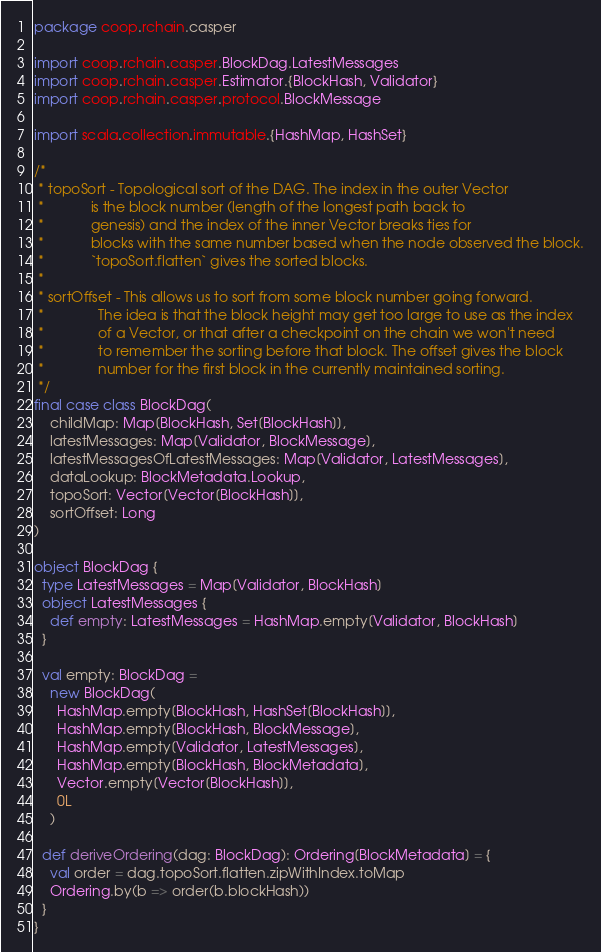Convert code to text. <code><loc_0><loc_0><loc_500><loc_500><_Scala_>package coop.rchain.casper

import coop.rchain.casper.BlockDag.LatestMessages
import coop.rchain.casper.Estimator.{BlockHash, Validator}
import coop.rchain.casper.protocol.BlockMessage

import scala.collection.immutable.{HashMap, HashSet}

/*
 * topoSort - Topological sort of the DAG. The index in the outer Vector
 *            is the block number (length of the longest path back to
 *            genesis) and the index of the inner Vector breaks ties for
 *            blocks with the same number based when the node observed the block.
 *            `topoSort.flatten` gives the sorted blocks.
 *
 * sortOffset - This allows us to sort from some block number going forward.
 *              The idea is that the block height may get too large to use as the index
 *              of a Vector, or that after a checkpoint on the chain we won't need
 *              to remember the sorting before that block. The offset gives the block
 *              number for the first block in the currently maintained sorting.
 */
final case class BlockDag(
    childMap: Map[BlockHash, Set[BlockHash]],
    latestMessages: Map[Validator, BlockMessage],
    latestMessagesOfLatestMessages: Map[Validator, LatestMessages],
    dataLookup: BlockMetadata.Lookup,
    topoSort: Vector[Vector[BlockHash]],
    sortOffset: Long
)

object BlockDag {
  type LatestMessages = Map[Validator, BlockHash]
  object LatestMessages {
    def empty: LatestMessages = HashMap.empty[Validator, BlockHash]
  }

  val empty: BlockDag =
    new BlockDag(
      HashMap.empty[BlockHash, HashSet[BlockHash]],
      HashMap.empty[BlockHash, BlockMessage],
      HashMap.empty[Validator, LatestMessages],
      HashMap.empty[BlockHash, BlockMetadata],
      Vector.empty[Vector[BlockHash]],
      0L
    )

  def deriveOrdering(dag: BlockDag): Ordering[BlockMetadata] = {
    val order = dag.topoSort.flatten.zipWithIndex.toMap
    Ordering.by(b => order(b.blockHash))
  }
}
</code> 